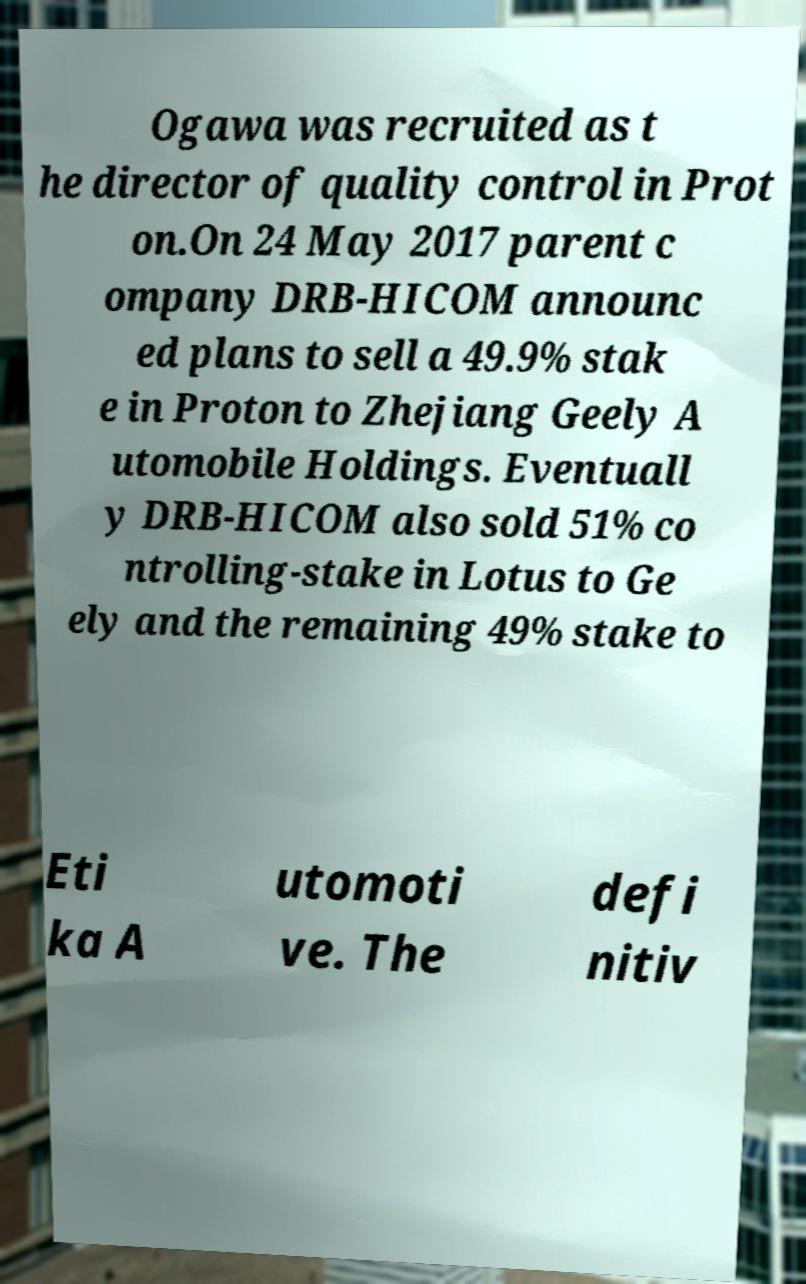There's text embedded in this image that I need extracted. Can you transcribe it verbatim? Ogawa was recruited as t he director of quality control in Prot on.On 24 May 2017 parent c ompany DRB-HICOM announc ed plans to sell a 49.9% stak e in Proton to Zhejiang Geely A utomobile Holdings. Eventuall y DRB-HICOM also sold 51% co ntrolling-stake in Lotus to Ge ely and the remaining 49% stake to Eti ka A utomoti ve. The defi nitiv 